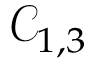Convert formula to latex. <formula><loc_0><loc_0><loc_500><loc_500>\mathcal { C } _ { 1 , 3 }</formula> 